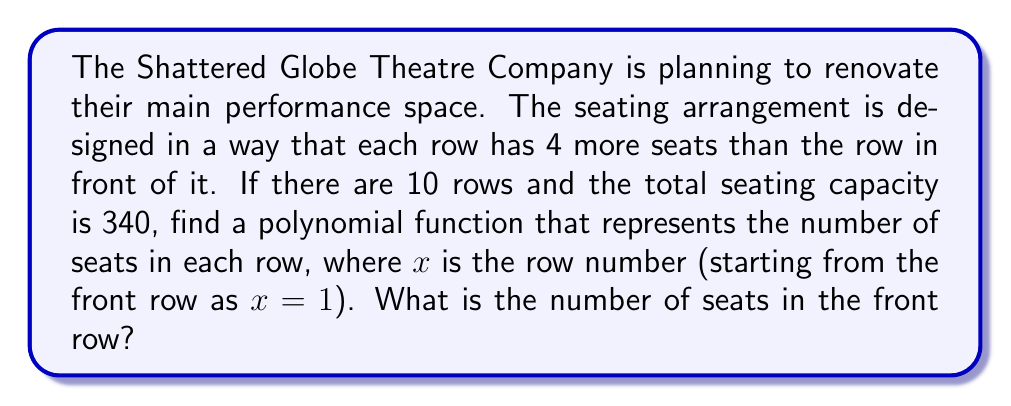Provide a solution to this math problem. Let's approach this step-by-step:

1) Let $S(x)$ be the number of seats in the $x$-th row. We know that each row has 4 more seats than the row in front of it. This means we can represent $S(x)$ as:

   $S(x) = a + 4(x-1)$

   where $a$ is the number of seats in the front row (when $x=1$).

2) We need to find the sum of seats for all 10 rows. This can be represented as:

   $\sum_{x=1}^{10} S(x) = 340$

3) Expanding this sum:

   $\sum_{x=1}^{10} (a + 4(x-1)) = 340$

4) This can be rewritten as:

   $10a + 4\sum_{x=1}^{10} (x-1) = 340$

5) The sum $\sum_{x=1}^{10} (x-1)$ is an arithmetic sequence from 0 to 9. We can use the formula for the sum of an arithmetic sequence:

   $\sum_{x=1}^{10} (x-1) = \frac{10(0+9)}{2} = 45$

6) Substituting this back:

   $10a + 4(45) = 340$
   $10a + 180 = 340$
   $10a = 160$
   $a = 16$

7) Therefore, the polynomial function for the number of seats in each row is:

   $S(x) = 16 + 4(x-1)$ or simplified: $S(x) = 4x + 12$

8) The number of seats in the front row is $a = 16$.
Answer: The polynomial function representing the number of seats in each row is $S(x) = 4x + 12$, and the number of seats in the front row is 16. 